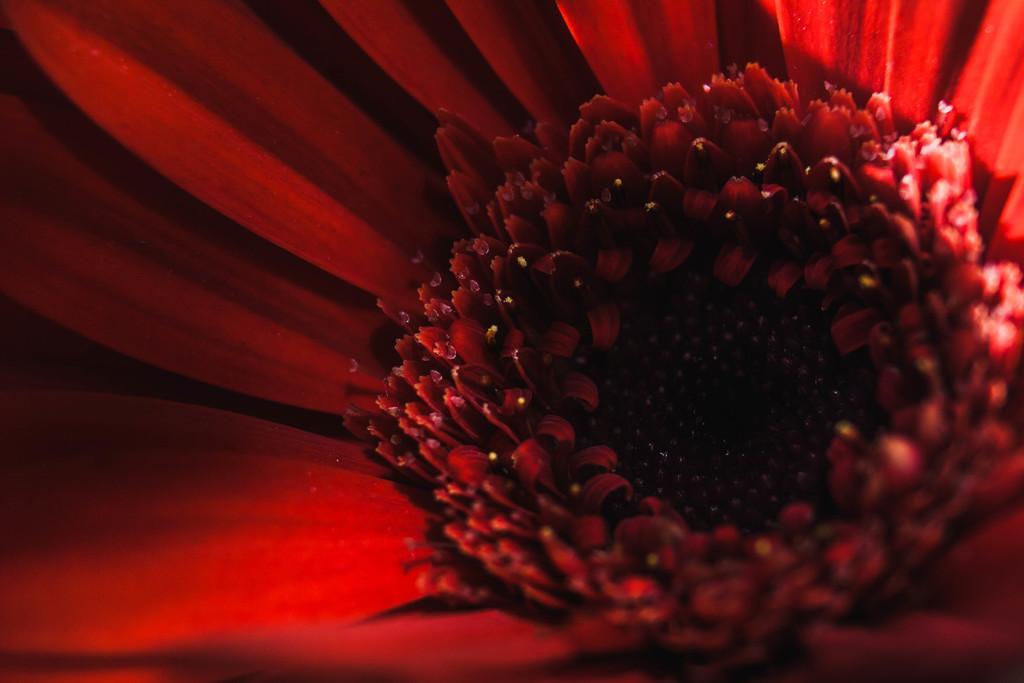How would you summarize this image in a sentence or two? There is a red color flower. 